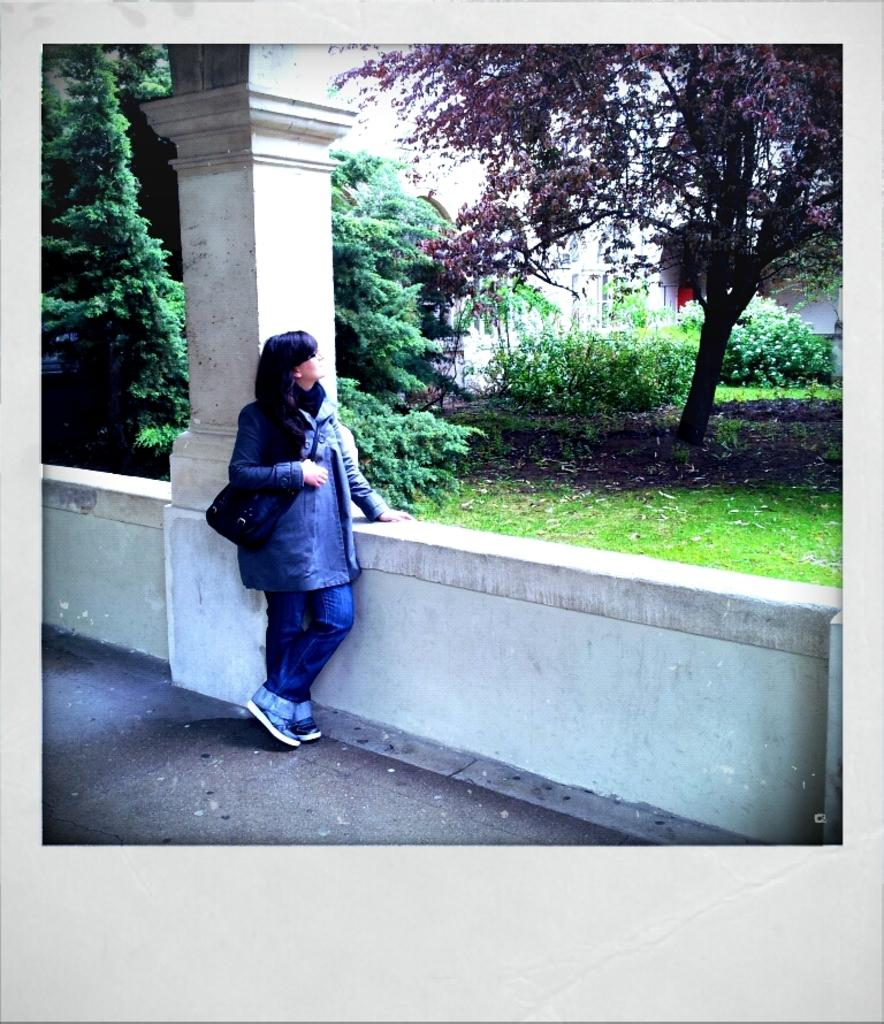What is the main subject of the image? There is a woman standing in the image. What is the woman wearing? The woman is wearing a bag. What other objects or structures can be seen in the image? There is a pillar and trees in the image. What is the chance of the queen visiting the location depicted in the image? There is no mention of a queen or any indication of a visit in the image, so it is impossible to determine the likelihood of a visit. 